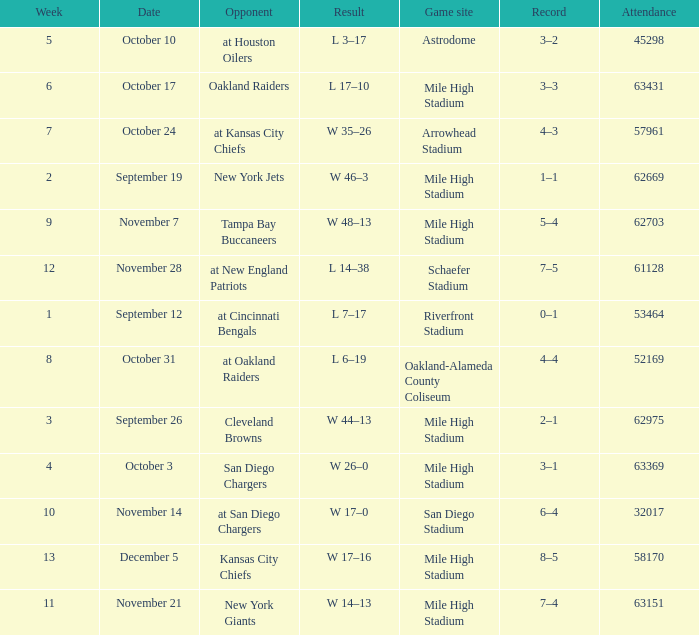Could you parse the entire table as a dict? {'header': ['Week', 'Date', 'Opponent', 'Result', 'Game site', 'Record', 'Attendance'], 'rows': [['5', 'October 10', 'at Houston Oilers', 'L 3–17', 'Astrodome', '3–2', '45298'], ['6', 'October 17', 'Oakland Raiders', 'L 17–10', 'Mile High Stadium', '3–3', '63431'], ['7', 'October 24', 'at Kansas City Chiefs', 'W 35–26', 'Arrowhead Stadium', '4–3', '57961'], ['2', 'September 19', 'New York Jets', 'W 46–3', 'Mile High Stadium', '1–1', '62669'], ['9', 'November 7', 'Tampa Bay Buccaneers', 'W 48–13', 'Mile High Stadium', '5–4', '62703'], ['12', 'November 28', 'at New England Patriots', 'L 14–38', 'Schaefer Stadium', '7–5', '61128'], ['1', 'September 12', 'at Cincinnati Bengals', 'L 7–17', 'Riverfront Stadium', '0–1', '53464'], ['8', 'October 31', 'at Oakland Raiders', 'L 6–19', 'Oakland-Alameda County Coliseum', '4–4', '52169'], ['3', 'September 26', 'Cleveland Browns', 'W 44–13', 'Mile High Stadium', '2–1', '62975'], ['4', 'October 3', 'San Diego Chargers', 'W 26–0', 'Mile High Stadium', '3–1', '63369'], ['10', 'November 14', 'at San Diego Chargers', 'W 17–0', 'San Diego Stadium', '6–4', '32017'], ['13', 'December 5', 'Kansas City Chiefs', 'W 17–16', 'Mile High Stadium', '8–5', '58170'], ['11', 'November 21', 'New York Giants', 'W 14–13', 'Mile High Stadium', '7–4', '63151']]} What was the date of the week 4 game? October 3. 